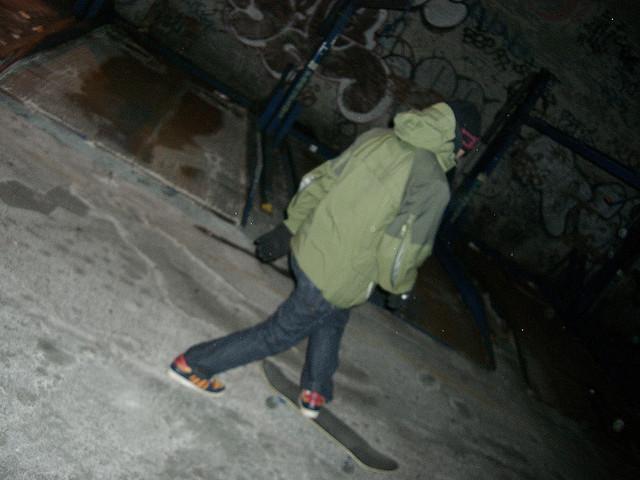How many legs are in the image?
Give a very brief answer. 2. 